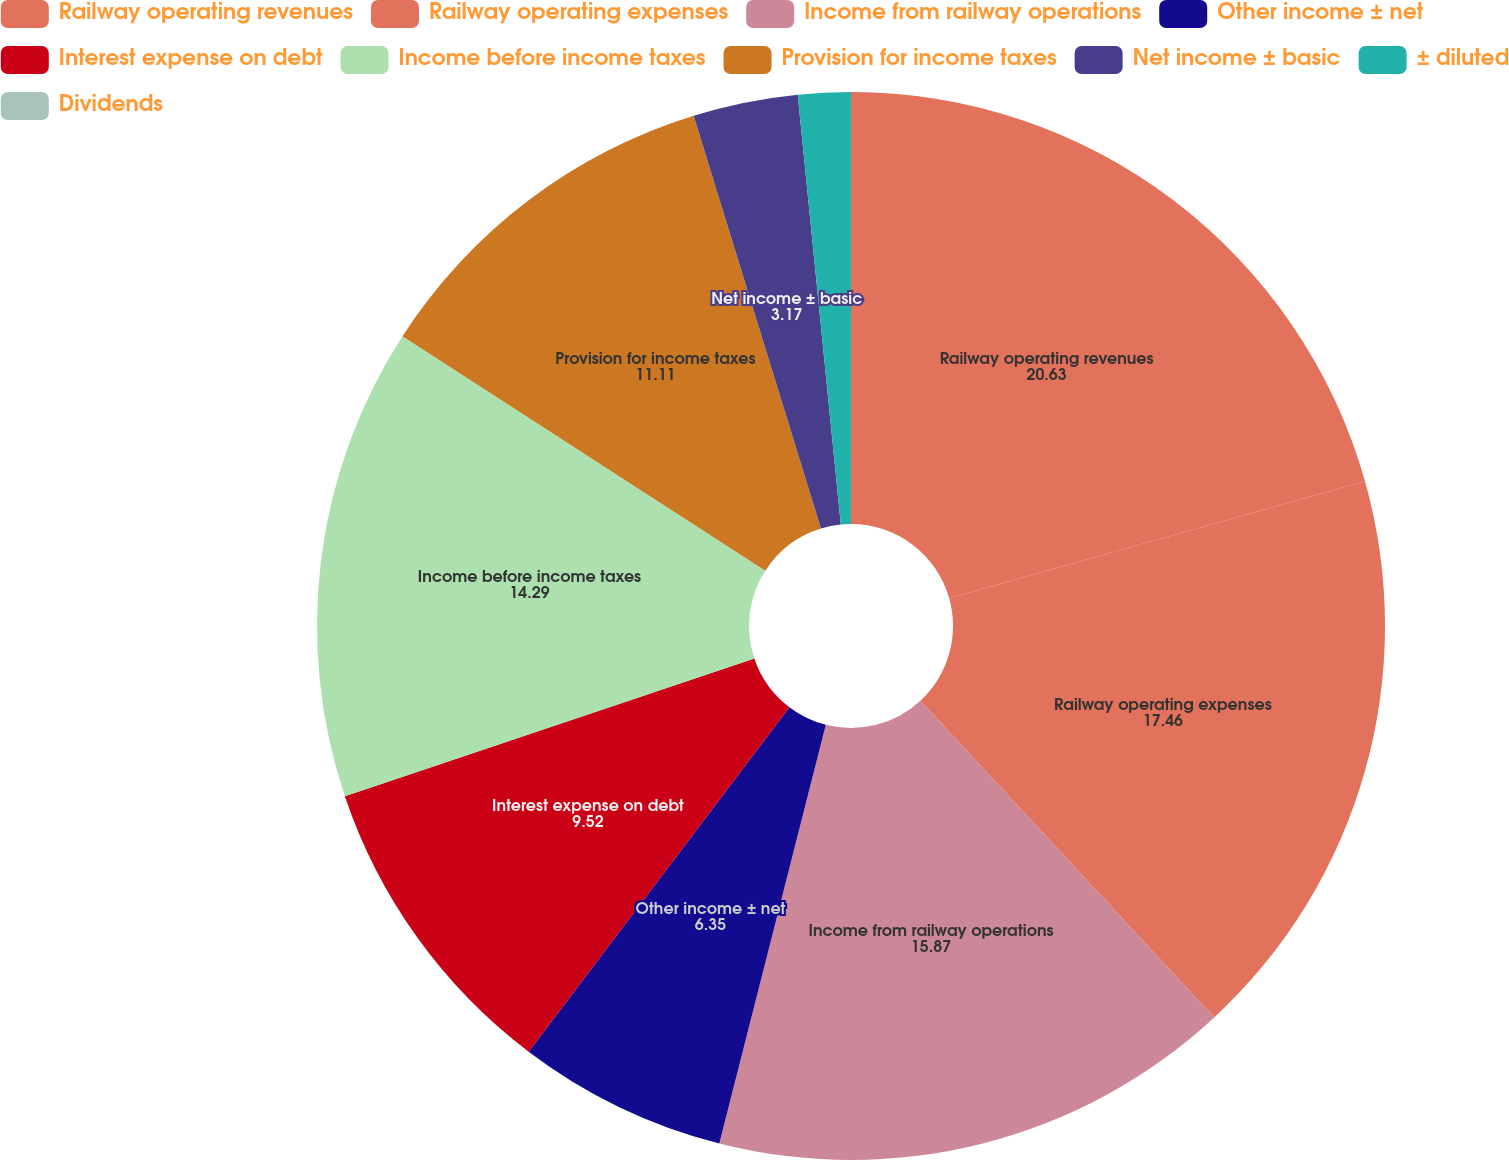Convert chart. <chart><loc_0><loc_0><loc_500><loc_500><pie_chart><fcel>Railway operating revenues<fcel>Railway operating expenses<fcel>Income from railway operations<fcel>Other income ± net<fcel>Interest expense on debt<fcel>Income before income taxes<fcel>Provision for income taxes<fcel>Net income ± basic<fcel>± diluted<fcel>Dividends<nl><fcel>20.63%<fcel>17.46%<fcel>15.87%<fcel>6.35%<fcel>9.52%<fcel>14.29%<fcel>11.11%<fcel>3.17%<fcel>1.59%<fcel>0.0%<nl></chart> 